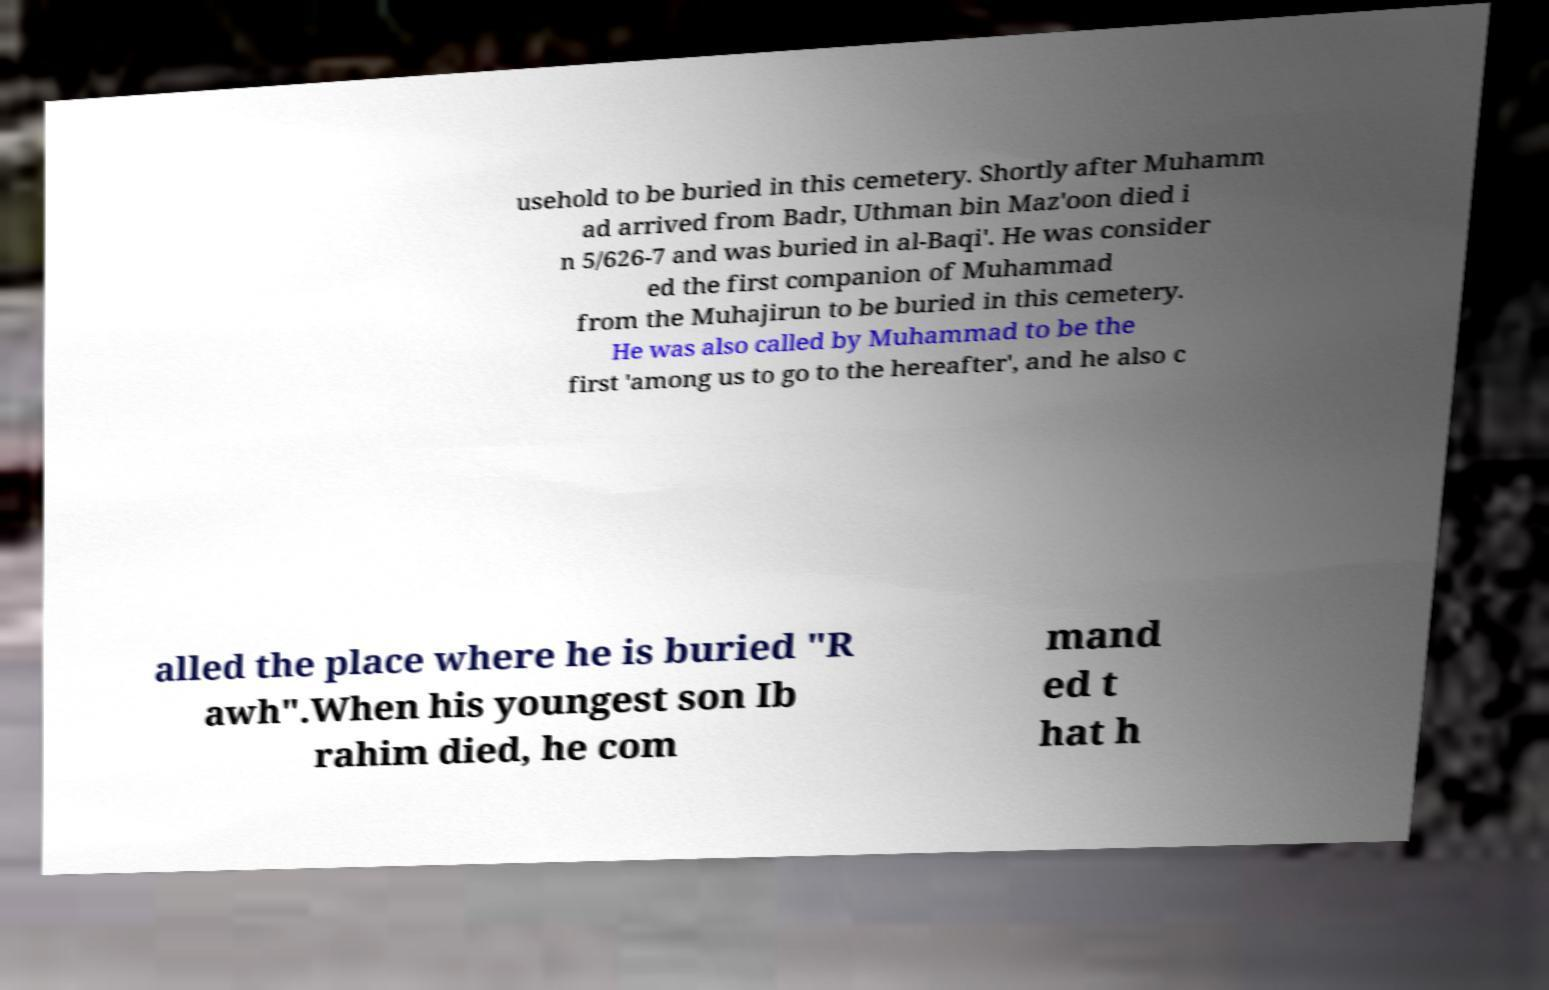Could you assist in decoding the text presented in this image and type it out clearly? usehold to be buried in this cemetery. Shortly after Muhamm ad arrived from Badr, Uthman bin Maz'oon died i n 5/626-7 and was buried in al-Baqi'. He was consider ed the first companion of Muhammad from the Muhajirun to be buried in this cemetery. He was also called by Muhammad to be the first 'among us to go to the hereafter', and he also c alled the place where he is buried "R awh".When his youngest son Ib rahim died, he com mand ed t hat h 